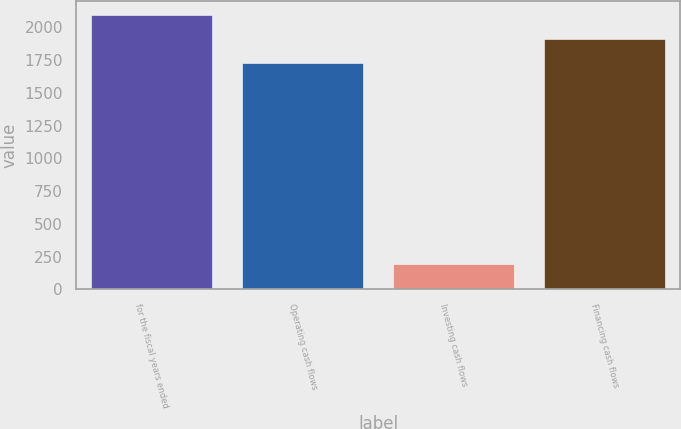<chart> <loc_0><loc_0><loc_500><loc_500><bar_chart><fcel>for the fiscal years ended<fcel>Operating cash flows<fcel>Investing cash flows<fcel>Financing cash flows<nl><fcel>2092.46<fcel>1727.7<fcel>192.2<fcel>1910.08<nl></chart> 